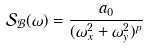<formula> <loc_0><loc_0><loc_500><loc_500>\mathcal { S _ { B } } ( \omega ) = \frac { a _ { 0 } } { ( \omega _ { x } ^ { 2 } + \omega _ { y } ^ { 2 } ) ^ { p } } \</formula> 